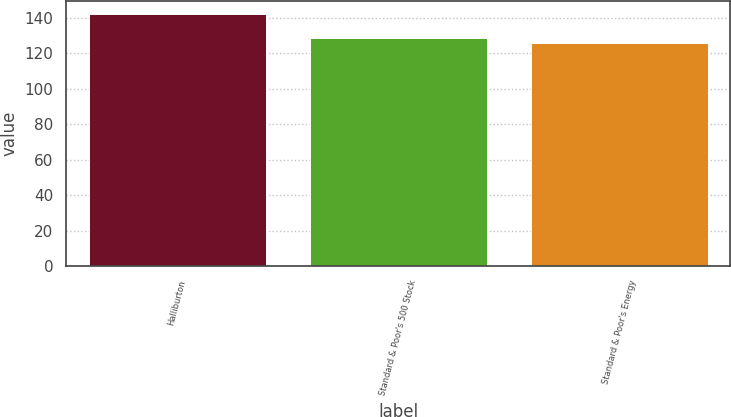Convert chart. <chart><loc_0><loc_0><loc_500><loc_500><bar_chart><fcel>Halliburton<fcel>Standard & Poor's 500 Stock<fcel>Standard & Poor's Energy<nl><fcel>142.06<fcel>128.68<fcel>125.63<nl></chart> 